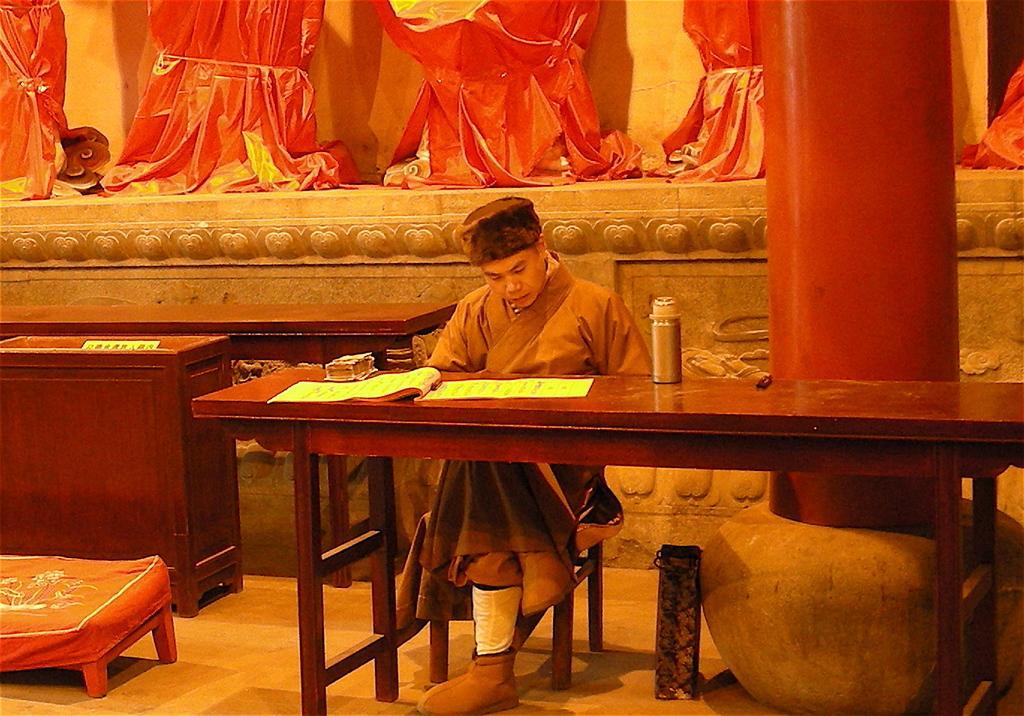Can you describe this image briefly? In this picture there is a man sitting on the chair, there is a table which has a book and a water bottle on it. Behind the person sitting there is a pole and there are some statues 